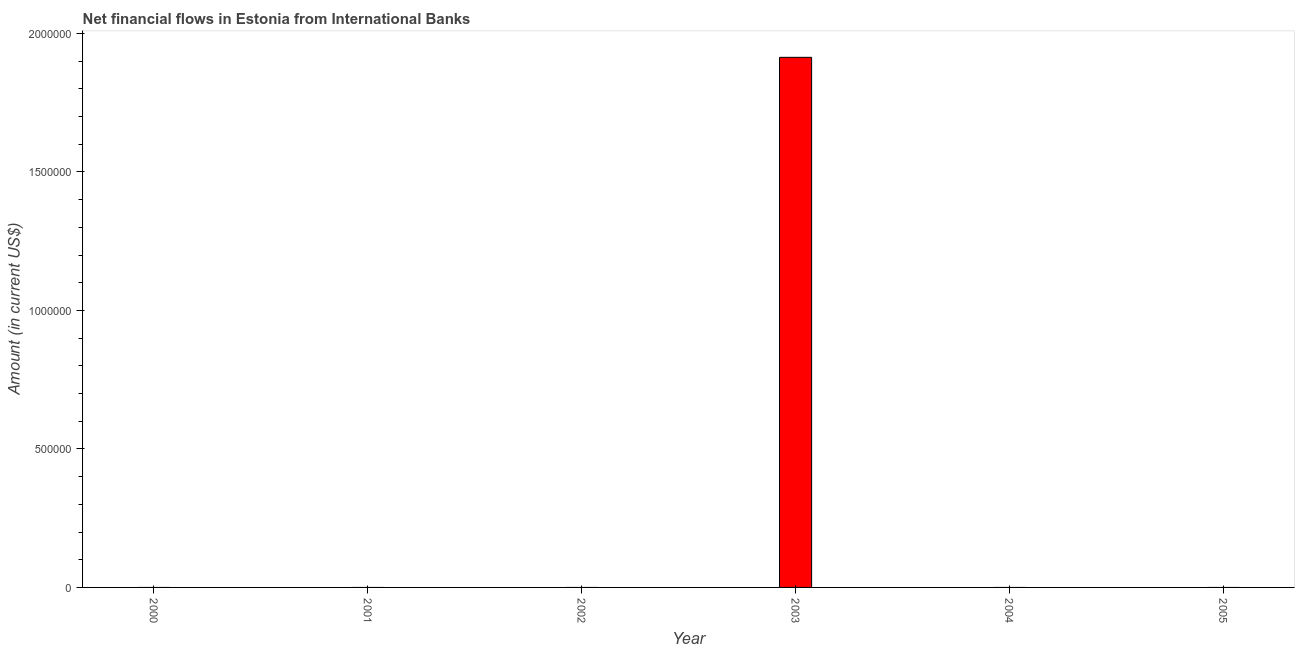Does the graph contain grids?
Provide a short and direct response. No. What is the title of the graph?
Offer a terse response. Net financial flows in Estonia from International Banks. What is the label or title of the X-axis?
Offer a terse response. Year. Across all years, what is the maximum net financial flows from ibrd?
Provide a succinct answer. 1.91e+06. What is the sum of the net financial flows from ibrd?
Keep it short and to the point. 1.91e+06. What is the average net financial flows from ibrd per year?
Your answer should be very brief. 3.19e+05. What is the difference between the highest and the lowest net financial flows from ibrd?
Your answer should be very brief. 1.91e+06. How many bars are there?
Provide a succinct answer. 1. Are all the bars in the graph horizontal?
Give a very brief answer. No. How many years are there in the graph?
Provide a short and direct response. 6. What is the Amount (in current US$) of 2001?
Your answer should be very brief. 0. What is the Amount (in current US$) of 2003?
Your answer should be very brief. 1.91e+06. What is the Amount (in current US$) of 2004?
Offer a terse response. 0. What is the Amount (in current US$) in 2005?
Your response must be concise. 0. 